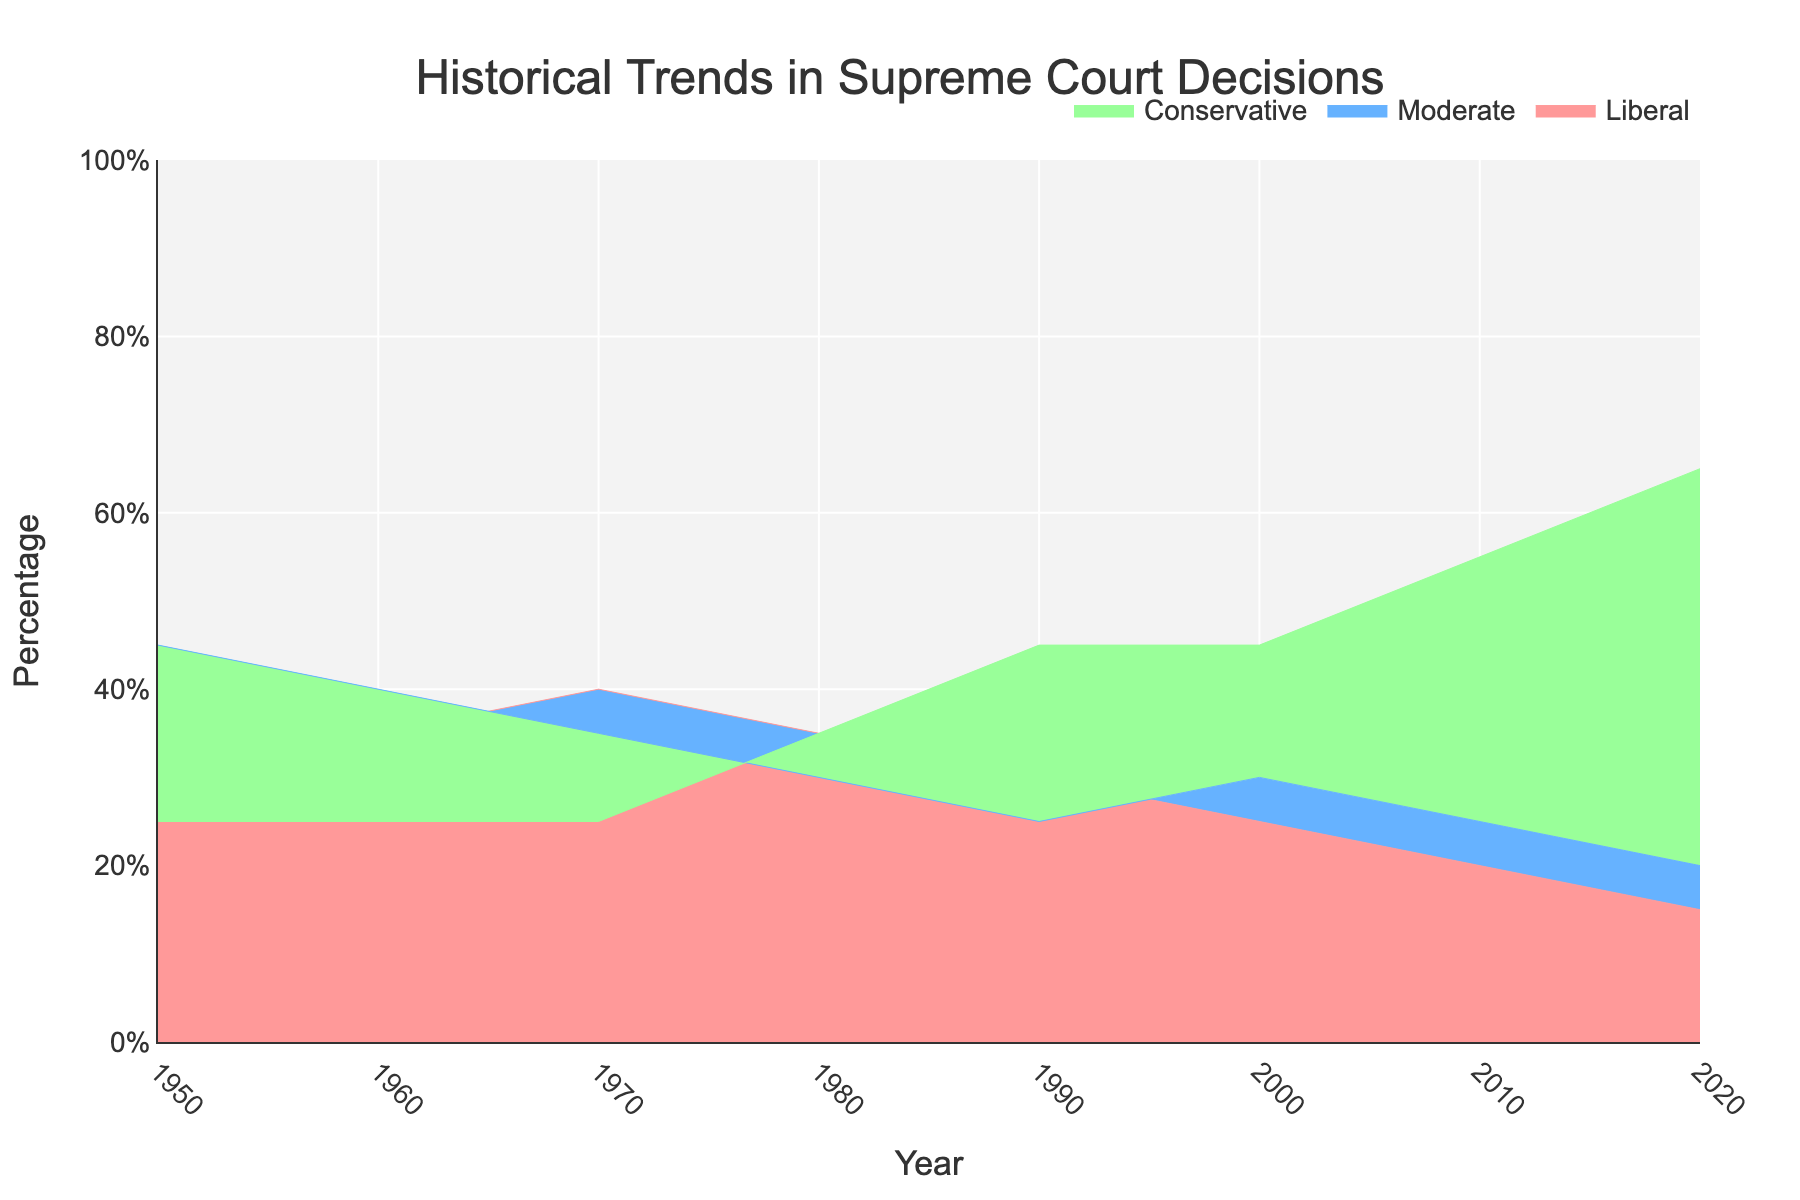What's the title of the figure? The title of the figure is usually prominently displayed and serves as an introduction or summary of the chart's content. It's located at the top of the figure.
Answer: Historical Trends in Supreme Court Decisions What are the categories tracked in the figure? By observing the legend or the different colors in the graph, you can see that the categories tracked in the figure are Liberal, Moderate, and Conservative ideologies.
Answer: Liberal, Moderate, Conservative Which ideology shows a decreasing trend from 1950 to 2020? By observing the lines associated with each ideology from left (1950) to right (2020), the line representing Liberals shows a consistent decline. This can be seen as the Liberal percentage drops from 30% in 1950 to 15% in 2020.
Answer: Liberal When did the Conservative ideology surpass the 50% mark? By observing the curve representing the Conservative ideology, you can see it crosses the 50% mark near the year's value 2010.
Answer: 2010 In which decade did the Moderate ideology drop the most? By evaluating the Moderate line, the most significant drop is observed between 1970 and 1980, where it went from 35% to 30%.
Answer: 1970-1980 How does the percentage of Moderate decisions in 2000 compare to that in 2020? The Moderate percentage in 2000 is 30%, whereas in 2020 it is 20%. By comparing these values directly, one can see that the percentage of Moderate decisions decreased by 10%.
Answer: The percentage decreased by 10% What is the total percentage of Liberal and Conservative ideologies combined in 1980? Add the percentage values of Liberal (35%) and Conservative (35%) in 1980. The sum is 35% + 35% = 70%.
Answer: 70% Which ideology had the lowest percentage in 1990? By examining the values for 1990, you can see that the Moderate ideology has the lowest percentage at 25%.
Answer: Moderate What is the average percentage of Conservative ideology from 2000 to 2020? Identify the percentages for the years 2000 (45%), 2010 (55%), and 2020 (65%). Sum these numbers: 45 + 55 + 65 = 165. Then, divide by the number of years: 165 / 3 = 55.
Answer: 55% By how much did the Conservative ideology increase from 1950 to 2020? The percentage for Conservative ideology in 1950 is 25%. In 2020, it is 65%. Subtract the initial value from the final value to find the increase: 65 - 25 = 40.
Answer: 40% 